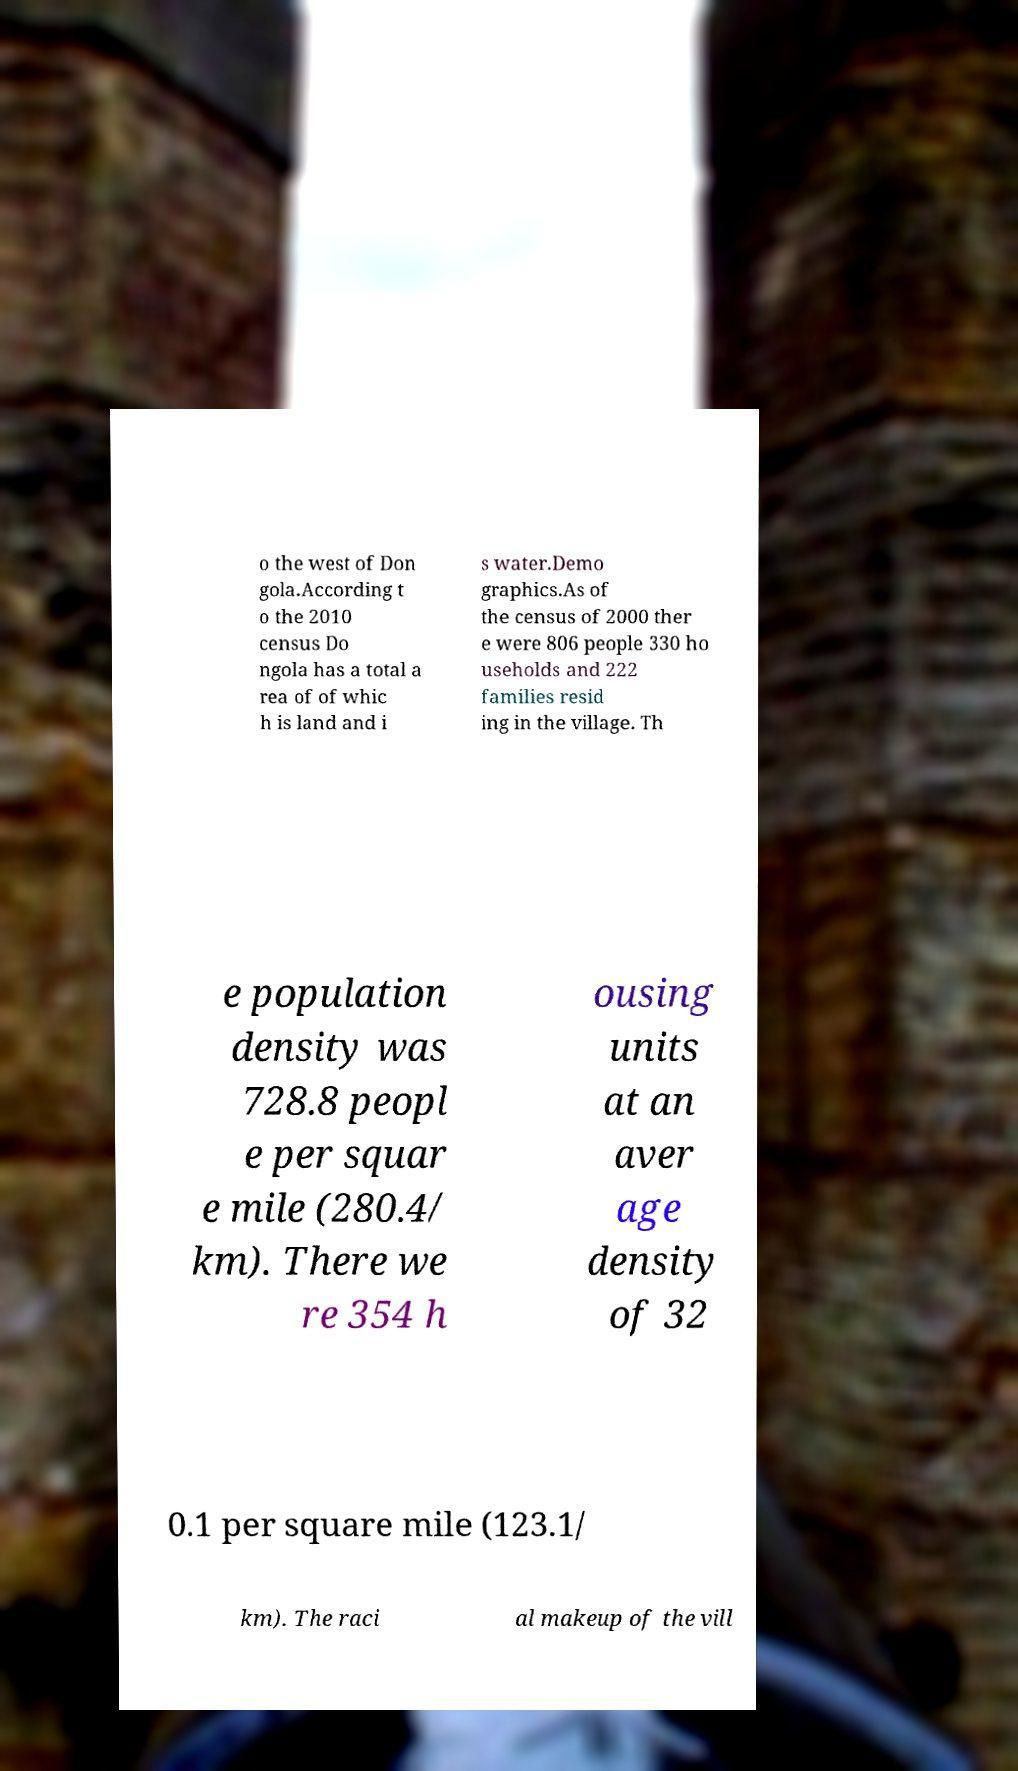For documentation purposes, I need the text within this image transcribed. Could you provide that? o the west of Don gola.According t o the 2010 census Do ngola has a total a rea of of whic h is land and i s water.Demo graphics.As of the census of 2000 ther e were 806 people 330 ho useholds and 222 families resid ing in the village. Th e population density was 728.8 peopl e per squar e mile (280.4/ km). There we re 354 h ousing units at an aver age density of 32 0.1 per square mile (123.1/ km). The raci al makeup of the vill 